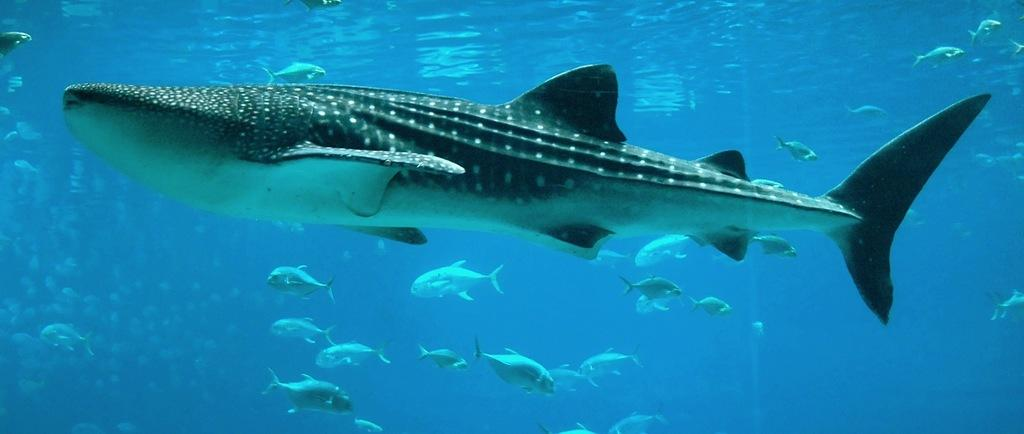Where is the picture taken? The picture is taken in water. What is the main subject in the foreground of the image? There is a whale in the foreground of the image. What other marine life can be seen in the background of the image? There are fishes in the background of the image. What type of development can be seen in the image? There is no development or construction visible in the image; it features a whale and fishes in water. What is the whale eating in the image? The image does not show the whale eating anything, so it cannot be determined what the whale might be consuming. 